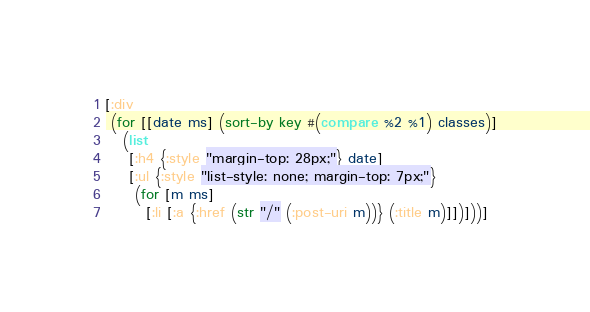<code> <loc_0><loc_0><loc_500><loc_500><_Clojure_>[:div
 (for [[date ms] (sort-by key #(compare %2 %1) classes)]
   (list
    [:h4 {:style "margin-top: 28px;"} date] 
    [:ul {:style "list-style: none; margin-top: 7px;"}
     (for [m ms]
       [:li [:a {:href (str "/" (:post-uri m))} (:title m)]])]))]

</code> 